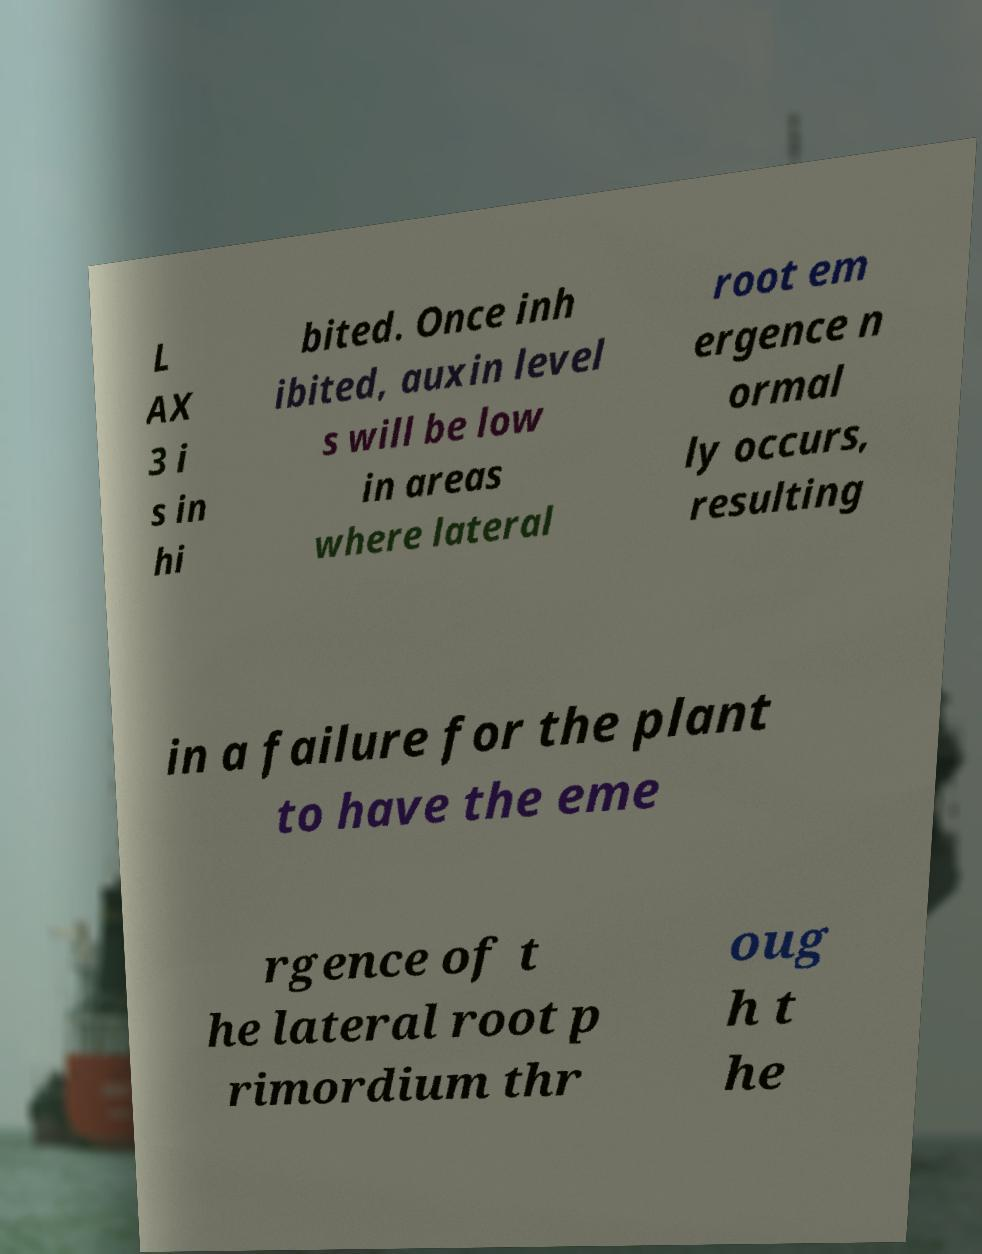There's text embedded in this image that I need extracted. Can you transcribe it verbatim? L AX 3 i s in hi bited. Once inh ibited, auxin level s will be low in areas where lateral root em ergence n ormal ly occurs, resulting in a failure for the plant to have the eme rgence of t he lateral root p rimordium thr oug h t he 